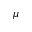Convert formula to latex. <formula><loc_0><loc_0><loc_500><loc_500>\mu</formula> 